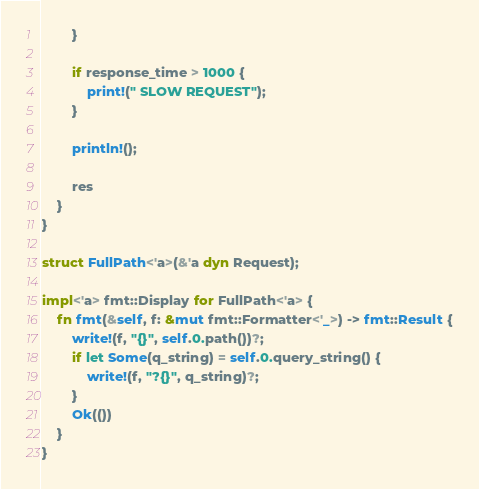<code> <loc_0><loc_0><loc_500><loc_500><_Rust_>        }

        if response_time > 1000 {
            print!(" SLOW REQUEST");
        }

        println!();

        res
    }
}

struct FullPath<'a>(&'a dyn Request);

impl<'a> fmt::Display for FullPath<'a> {
    fn fmt(&self, f: &mut fmt::Formatter<'_>) -> fmt::Result {
        write!(f, "{}", self.0.path())?;
        if let Some(q_string) = self.0.query_string() {
            write!(f, "?{}", q_string)?;
        }
        Ok(())
    }
}
</code> 